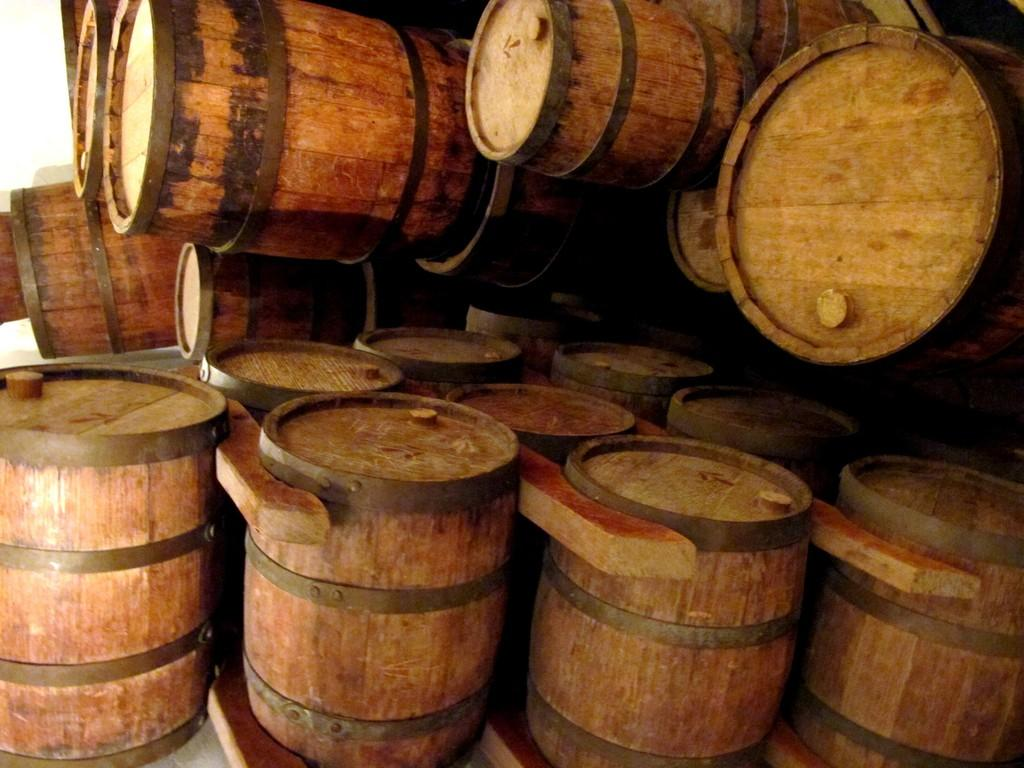What type of objects are present in the image? There is a group of wooden barrels in the image. Can you describe the material of the barrels? The barrels are made of wood. How many barrels are in the group? The number of barrels is not specified in the facts, so it cannot be determined from the image. Is there a cave visible in the image? No, there is no cave present in the image; it only features a group of wooden barrels. 